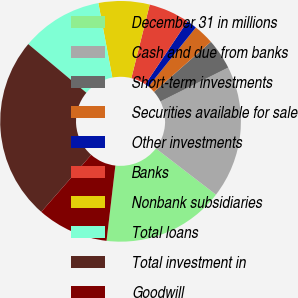Convert chart. <chart><loc_0><loc_0><loc_500><loc_500><pie_chart><fcel>December 31 in millions<fcel>Cash and due from banks<fcel>Short-term investments<fcel>Securities available for sale<fcel>Other investments<fcel>Banks<fcel>Nonbank subsidiaries<fcel>Total loans<fcel>Total investment in<fcel>Goodwill<nl><fcel>16.43%<fcel>17.8%<fcel>4.12%<fcel>2.75%<fcel>1.38%<fcel>5.48%<fcel>6.85%<fcel>10.96%<fcel>24.64%<fcel>9.59%<nl></chart> 